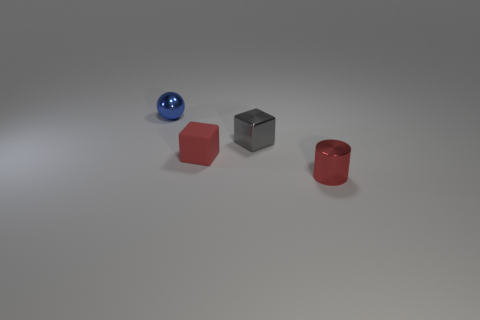Do the red thing that is behind the red metallic cylinder and the small red cylinder have the same material?
Offer a terse response. No. Is there anything else that has the same material as the sphere?
Provide a succinct answer. Yes. There is a red thing to the left of the shiny thing on the right side of the gray metallic cube; what number of tiny red cubes are to the right of it?
Your answer should be compact. 0. The blue sphere is what size?
Your answer should be very brief. Small. Do the metal sphere and the tiny cylinder have the same color?
Give a very brief answer. No. There is a shiny object that is behind the small gray metal thing; what is its size?
Your response must be concise. Small. There is a block on the right side of the small matte cube; does it have the same color as the metallic object that is to the left of the red matte block?
Your answer should be very brief. No. What number of other things are the same shape as the tiny gray object?
Give a very brief answer. 1. Are there the same number of shiny balls that are to the right of the shiny cube and red rubber cubes that are in front of the tiny shiny cylinder?
Offer a very short reply. Yes. Are the object that is on the left side of the red matte thing and the small red object behind the tiny red metal cylinder made of the same material?
Your answer should be compact. No. 